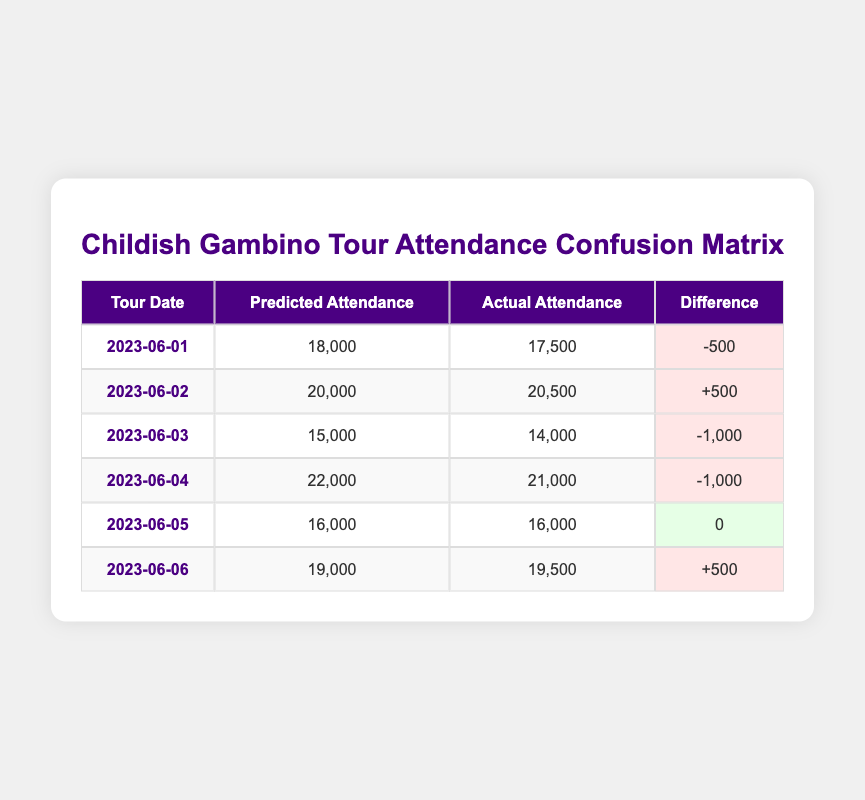What was the actual attendance on 2023-06-01? The table shows that the actual attendance for the tour date 2023-06-01 is listed as 17,500.
Answer: 17,500 What was the predicted attendance on 2023-06-04? According to the table, the predicted attendance for 2023-06-04 is 22,000.
Answer: 22,000 How many concerts had a mismatch between predicted and actual attendance? The table indicates that there are four cases where the predicted attendance does not match the actual attendance (2023-06-01, 2023-06-02, 2023-06-03, and 2023-06-04).
Answer: Four What is the total difference in attendance across all dates? By adding up the differences for all dates: (-500) + (+500) + (-1,000) + (-1,000) + (0) + (+500) gives a total difference of -1,500.
Answer: -1,500 Was the actual attendance on 2023-06-05 equal to the predicted attendance? The table shows that both the predicted and actual attendance for 2023-06-05 are 16,000, confirming they are equal.
Answer: Yes On which date was the discrepancy in attendance the largest? The differences are -500, +500, -1,000, -1,000, 0, and +500. The largest discrepancy (in absolute value) is -1,000 for both 2023-06-03 and 2023-06-04.
Answer: 2023-06-03 and 2023-06-04 What is the average actual attendance across all concert dates? Adding actual attendance values (17,500 + 20,500 + 14,000 + 21,000 + 16,000 + 19,500) results in 108,500. Dividing by 6 gives an average of 18,083.33.
Answer: 18,083.33 Was there any concert where the actual attendance exceeded the predicted attendance? The table shows that on 2023-06-02, the actual attendance (20,500) exceeded the predicted attendance (20,000).
Answer: Yes What was the smallest difference in attendance recorded? Reviewing the differences listed (-500, +500, -1,000, -1,000, 0, +500), the smallest difference is 0, which occurred on 2023-06-05.
Answer: 0 